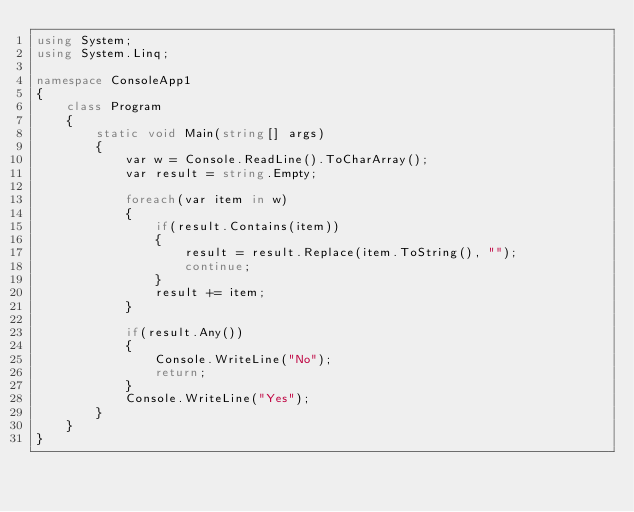<code> <loc_0><loc_0><loc_500><loc_500><_C#_>using System;
using System.Linq;

namespace ConsoleApp1
{
    class Program
    {
        static void Main(string[] args)
        {
            var w = Console.ReadLine().ToCharArray();
            var result = string.Empty;

            foreach(var item in w)
            {
                if(result.Contains(item))
                {
                    result = result.Replace(item.ToString(), "");
                    continue;
                }
                result += item;
            }
            
            if(result.Any())
            {
                Console.WriteLine("No");
                return;
            }
            Console.WriteLine("Yes");
        }
    }
}
</code> 